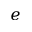<formula> <loc_0><loc_0><loc_500><loc_500>e</formula> 